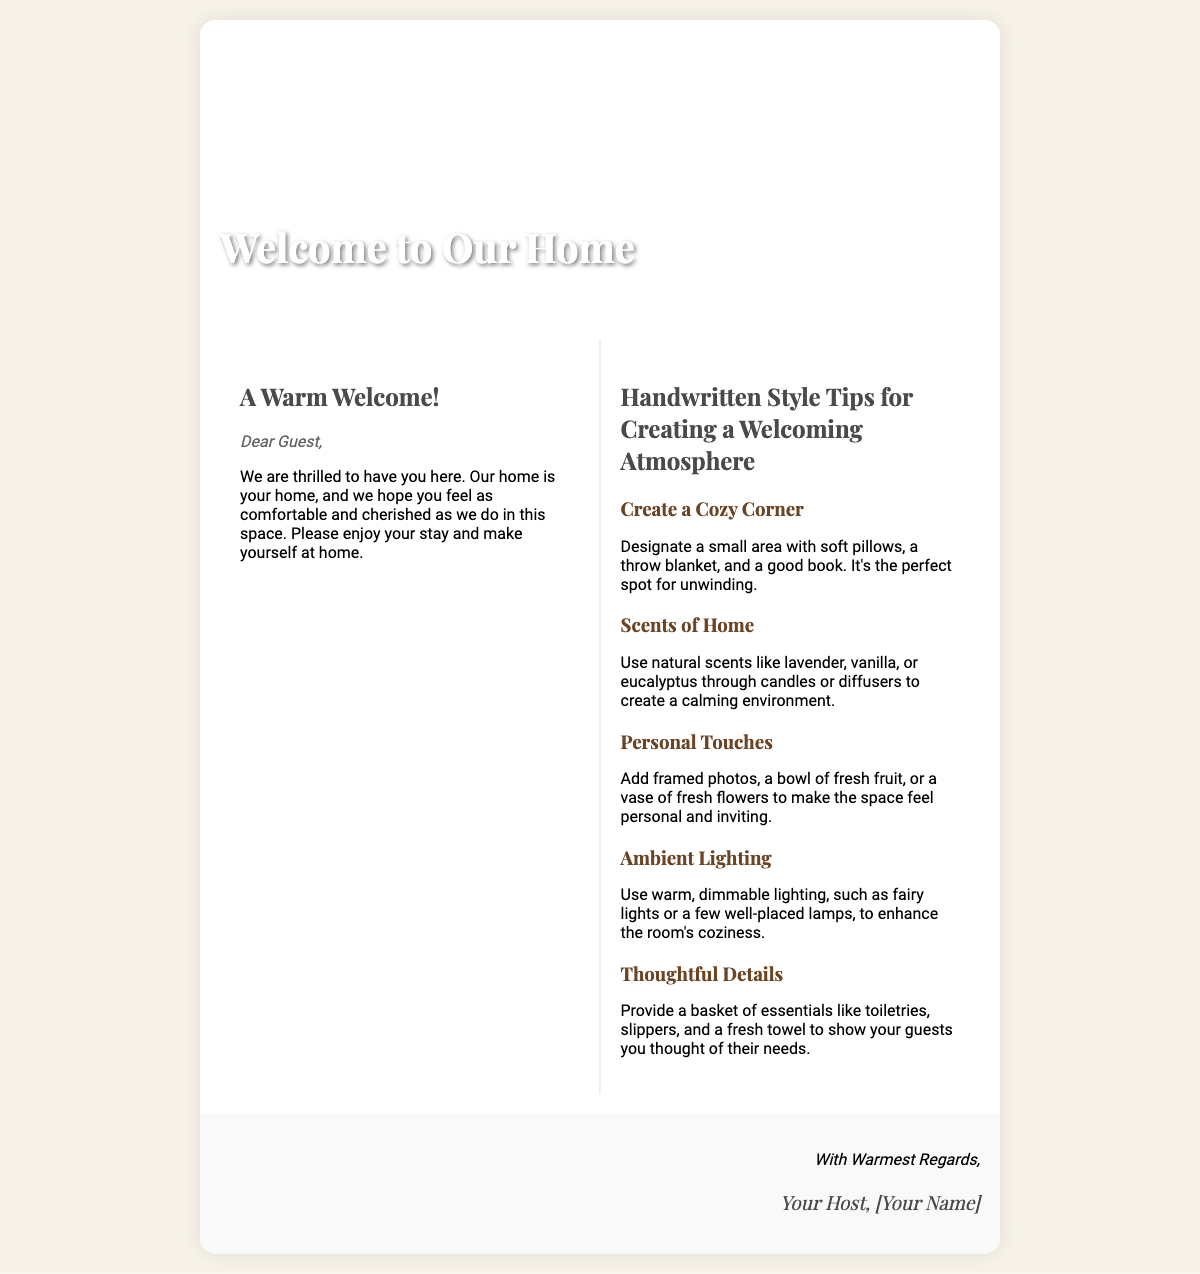What is the title of the card? The title of the card is prominently displayed at the top section of the document.
Answer: Welcome to Our Home Who is the intended recipient of the message? The document addresses a specific group of people directly within the opening message.
Answer: Guest What are the tips provided for creating a welcoming atmosphere? The document lists multiple specific tips in the section dedicated to handwritten style tips.
Answer: Cozy Corner, Scents of Home, Personal Touches, Ambient Lighting, Thoughtful Details How many tips are included in the document? The document provides a list of tips and specifies their count by the number of list items shown.
Answer: Five What style of font is used for the header? The document specifies the font families used for different sections of the card, particularly the header.
Answer: Playfair Display What type of atmosphere do the tips aim to create? The description of the tips implies a certain quality and feeling they are intended to convey.
Answer: Welcoming What additional features contribute to making guests feel at home? Information within the document reveals extra details that enhance guest comfort.
Answer: Essentials basket Who signed off the card? The document concludes with this information, indicating who the host is.
Answer: Your Host, [Your Name] 